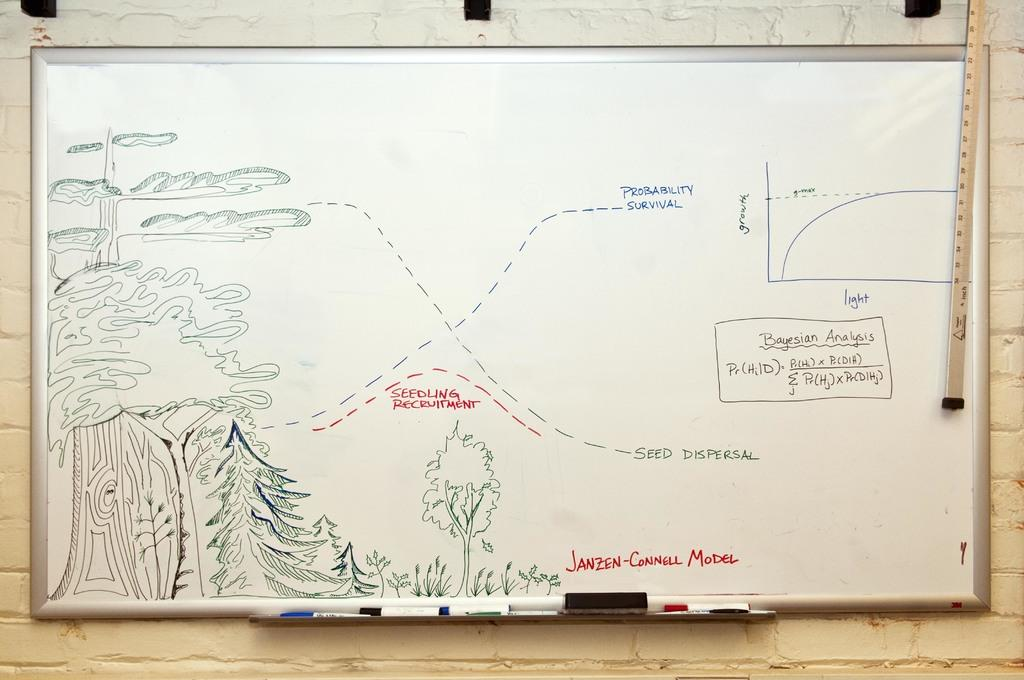<image>
Render a clear and concise summary of the photo. A diagram on white paper with the words Seedling Recruitment visible. 